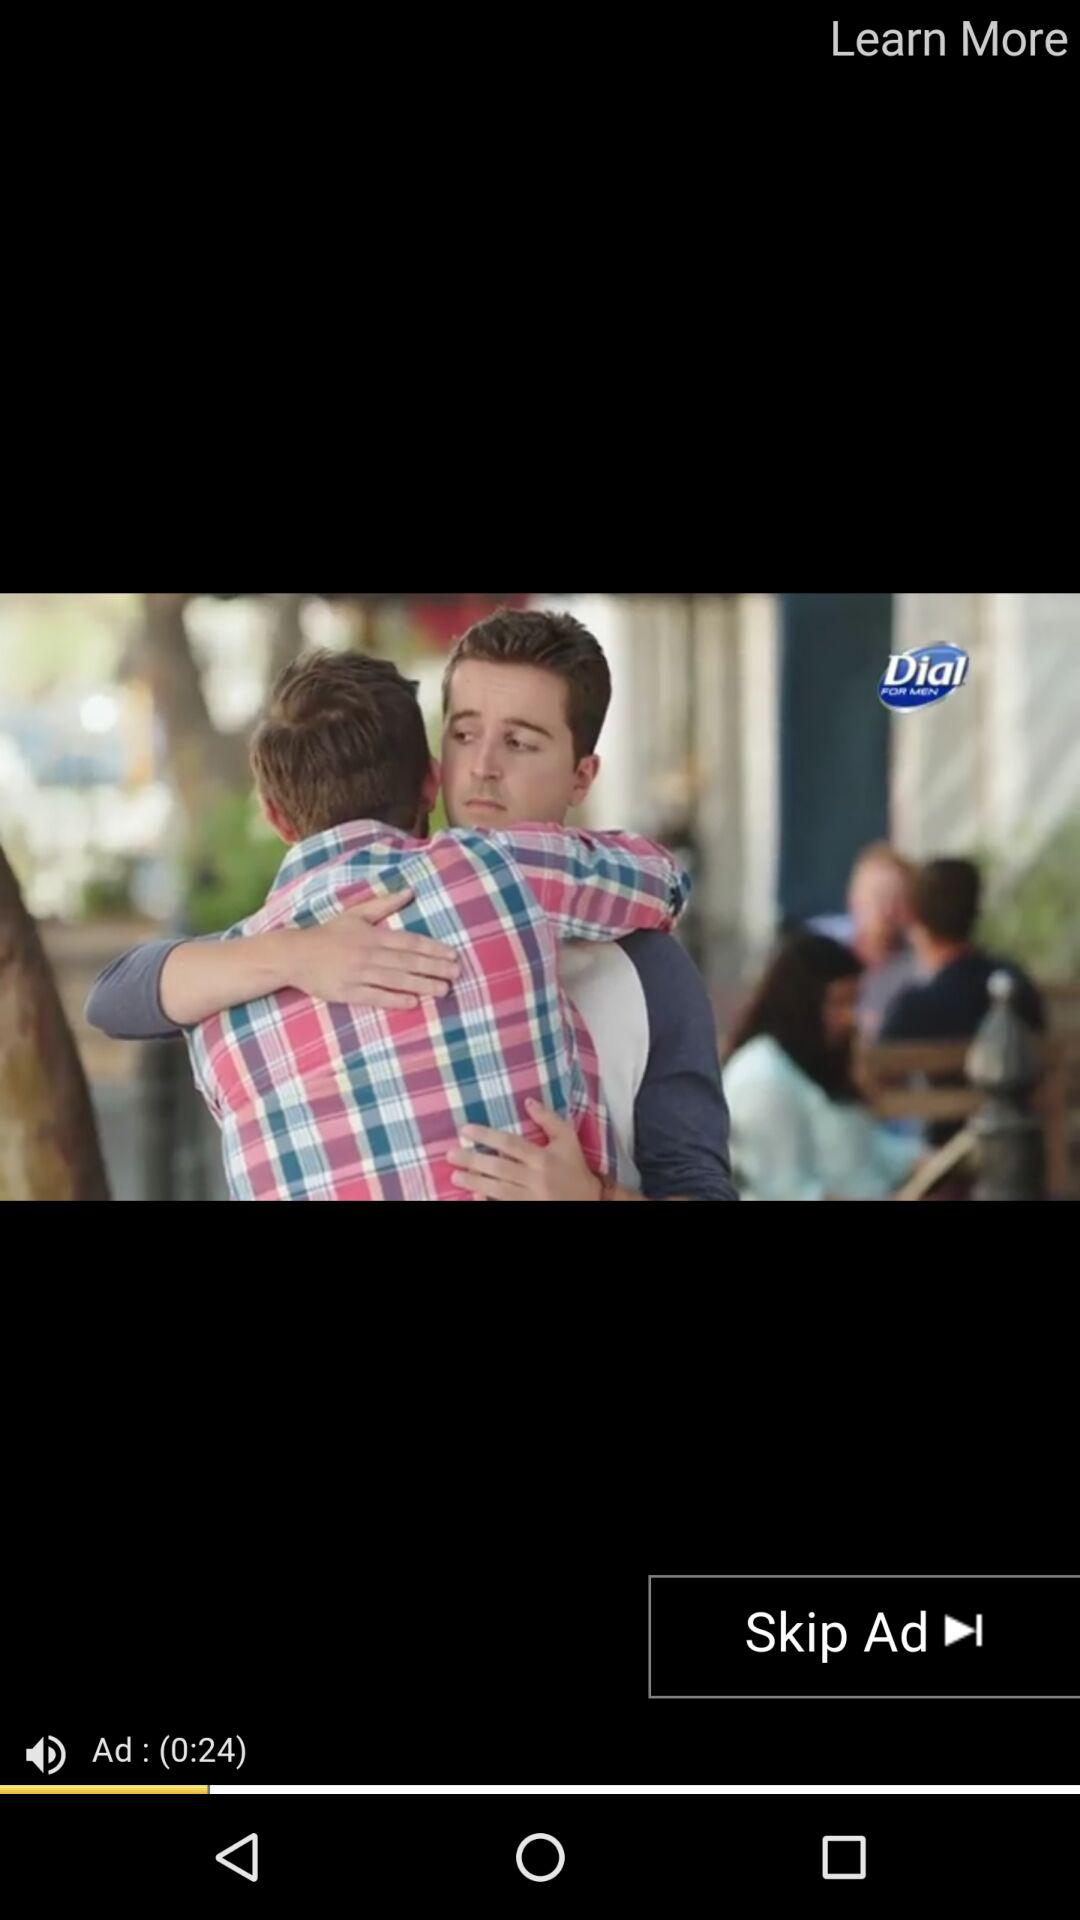How many seconds long is the ad?
Answer the question using a single word or phrase. 24 